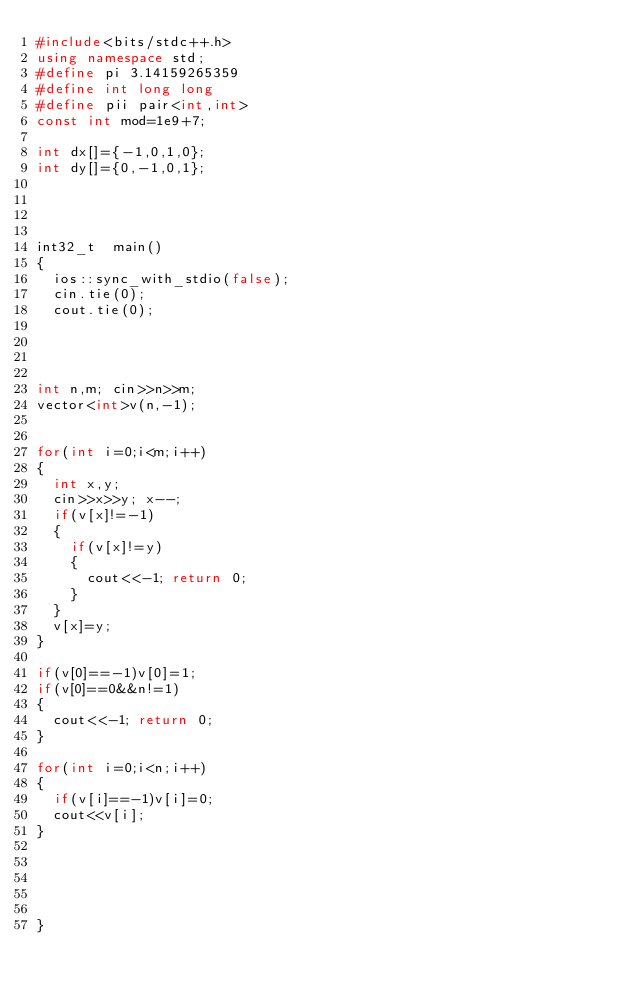Convert code to text. <code><loc_0><loc_0><loc_500><loc_500><_C++_>#include<bits/stdc++.h>
using namespace std;
#define pi 3.14159265359
#define int long long
#define pii pair<int,int>
const int mod=1e9+7;

int dx[]={-1,0,1,0};
int dy[]={0,-1,0,1};




int32_t  main()
{ 
  ios::sync_with_stdio(false);
  cin.tie(0);
  cout.tie(0);
 



int n,m; cin>>n>>m;
vector<int>v(n,-1);


for(int i=0;i<m;i++)
{
  int x,y;
  cin>>x>>y; x--;
  if(v[x]!=-1)
  {
    if(v[x]!=y)
    {
      cout<<-1; return 0;
    }
  }
  v[x]=y;
}

if(v[0]==-1)v[0]=1;
if(v[0]==0&&n!=1)
{
  cout<<-1; return 0;
}

for(int i=0;i<n;i++)
{
  if(v[i]==-1)v[i]=0;
  cout<<v[i];
}




  
}

</code> 